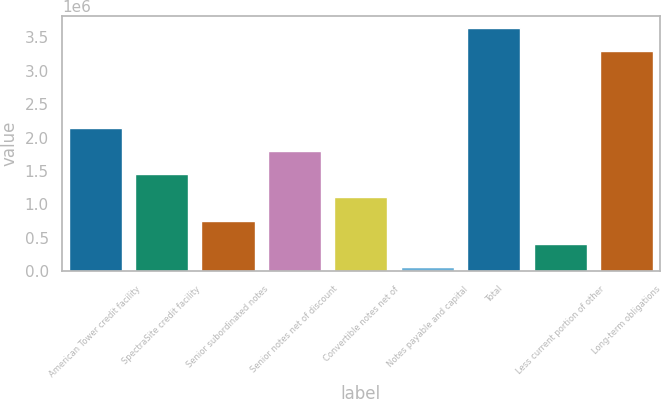Convert chart. <chart><loc_0><loc_0><loc_500><loc_500><bar_chart><fcel>American Tower credit facility<fcel>SpectraSite credit facility<fcel>Senior subordinated notes<fcel>Senior notes net of discount<fcel>Convertible notes net of<fcel>Notes payable and capital<fcel>Total<fcel>Less current portion of other<fcel>Long-term obligations<nl><fcel>2.14974e+06<fcel>1.45311e+06<fcel>756474<fcel>1.80143e+06<fcel>1.10479e+06<fcel>59838<fcel>3.63743e+06<fcel>408156<fcel>3.28911e+06<nl></chart> 